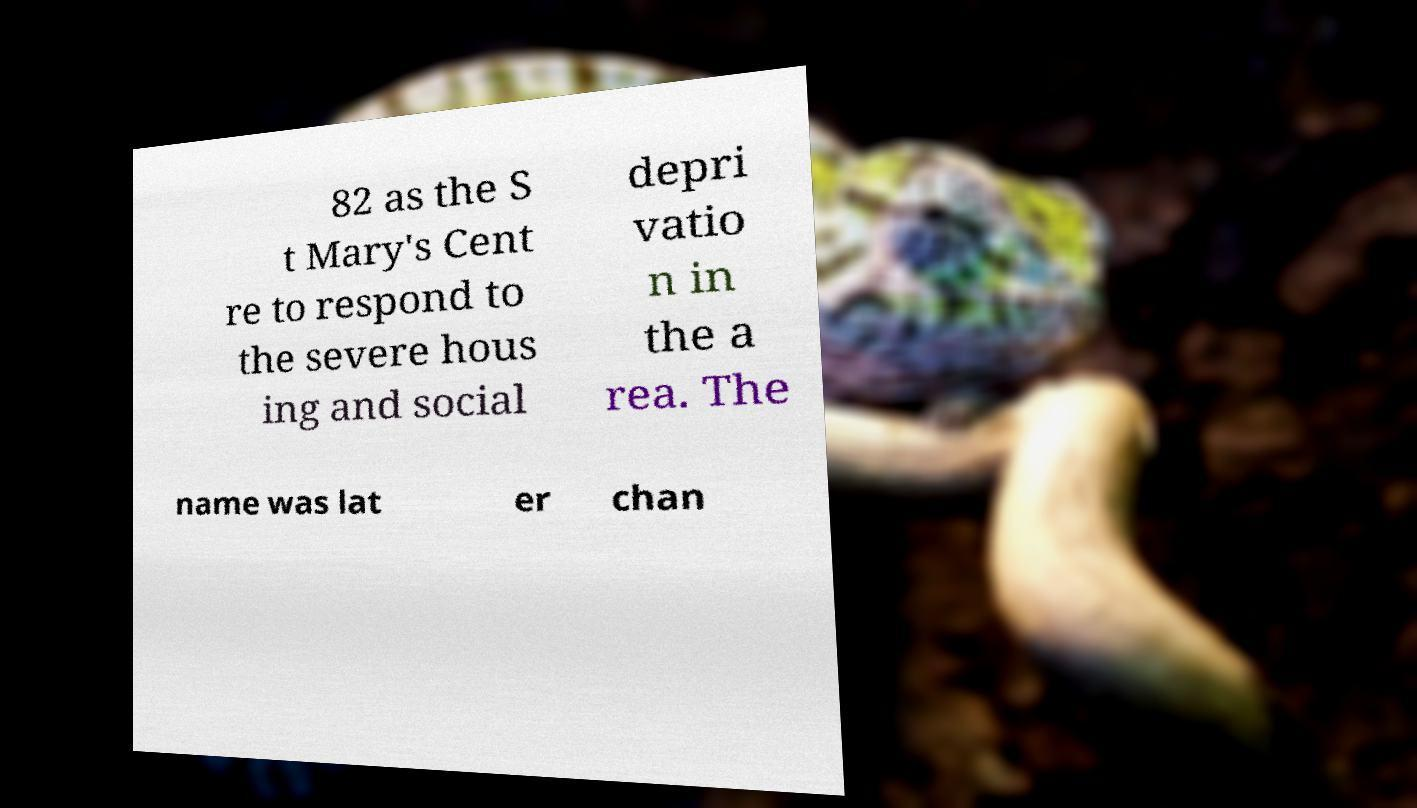Please read and relay the text visible in this image. What does it say? 82 as the S t Mary's Cent re to respond to the severe hous ing and social depri vatio n in the a rea. The name was lat er chan 